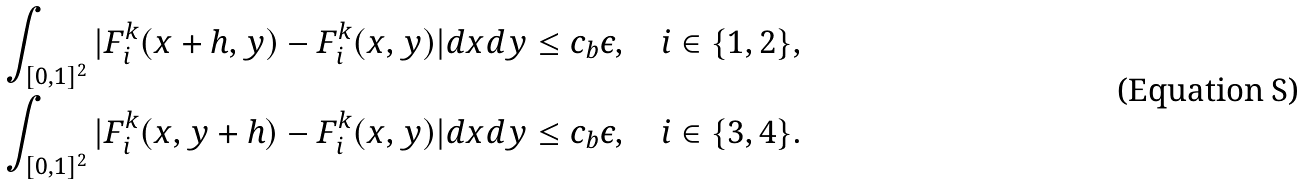<formula> <loc_0><loc_0><loc_500><loc_500>& \int _ { [ 0 , 1 ] ^ { 2 } } | F ^ { k } _ { i } ( x + h , y ) - F ^ { k } _ { i } ( x , y ) | d x d y \leq c _ { b } \epsilon , \quad i \in \{ 1 , 2 \} , \\ & \int _ { [ 0 , 1 ] ^ { 2 } } | F ^ { k } _ { i } ( x , y + h ) - F ^ { k } _ { i } ( x , y ) | d x d y \leq c _ { b } \epsilon , \quad i \in \{ 3 , 4 \} .</formula> 